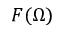Convert formula to latex. <formula><loc_0><loc_0><loc_500><loc_500>F ( \Omega )</formula> 